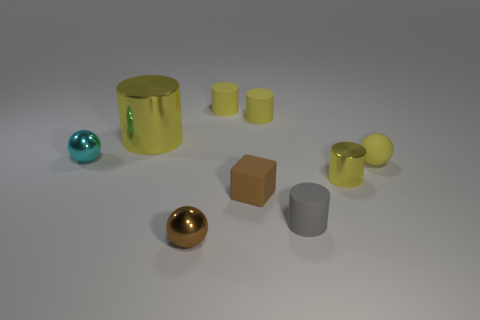Subtract all tiny rubber cylinders. How many cylinders are left? 2 Subtract all spheres. How many objects are left? 6 Subtract all yellow spheres. How many spheres are left? 2 Add 6 large shiny cylinders. How many large shiny cylinders exist? 7 Subtract 0 cyan blocks. How many objects are left? 9 Subtract 2 spheres. How many spheres are left? 1 Subtract all red blocks. Subtract all green spheres. How many blocks are left? 1 Subtract all blue cylinders. How many blue spheres are left? 0 Subtract all tiny rubber blocks. Subtract all large objects. How many objects are left? 7 Add 8 cyan shiny spheres. How many cyan shiny spheres are left? 9 